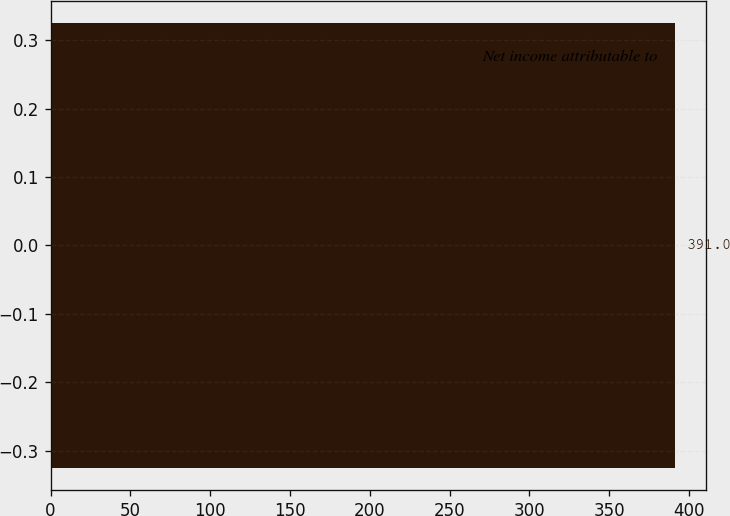Convert chart. <chart><loc_0><loc_0><loc_500><loc_500><bar_chart><fcel>Net income attributable to<nl><fcel>391<nl></chart> 